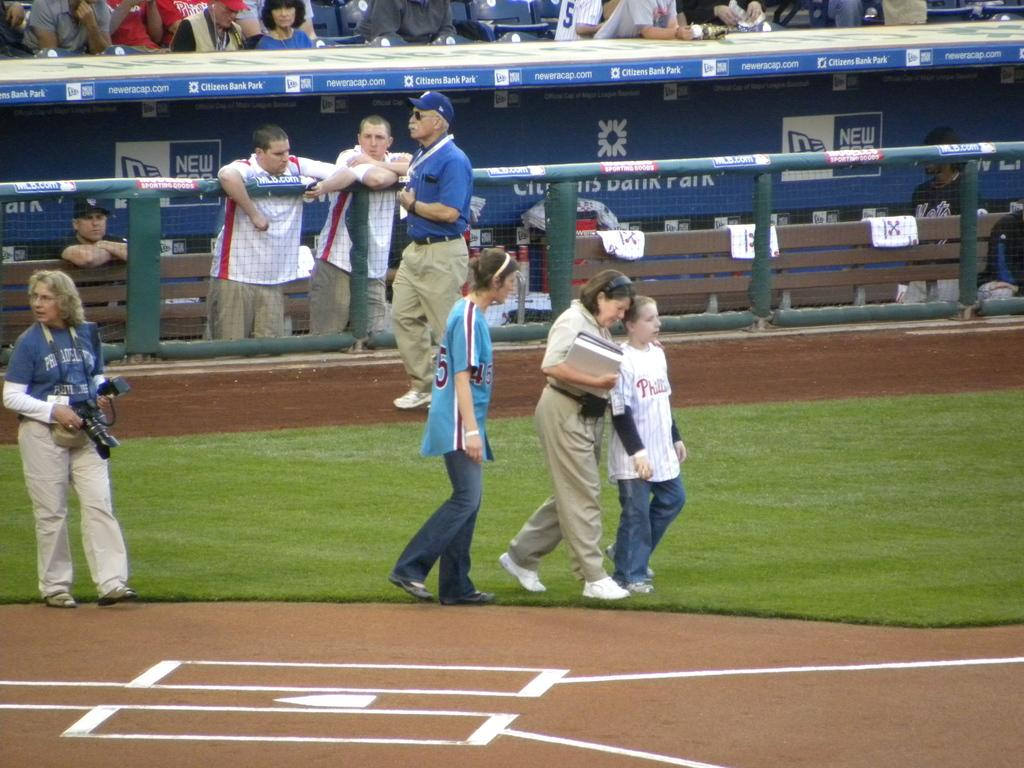Provide a one-sentence caption for the provided image. several people are on the baseball field that is sponsored by citizens bank. 